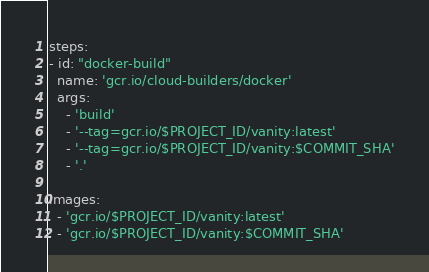<code> <loc_0><loc_0><loc_500><loc_500><_YAML_>steps:
- id: "docker-build"
  name: 'gcr.io/cloud-builders/docker'
  args:
    - 'build'
    - '--tag=gcr.io/$PROJECT_ID/vanity:latest'
    - '--tag=gcr.io/$PROJECT_ID/vanity:$COMMIT_SHA'
    - '.'

images: 
  - 'gcr.io/$PROJECT_ID/vanity:latest'
  - 'gcr.io/$PROJECT_ID/vanity:$COMMIT_SHA'
</code> 